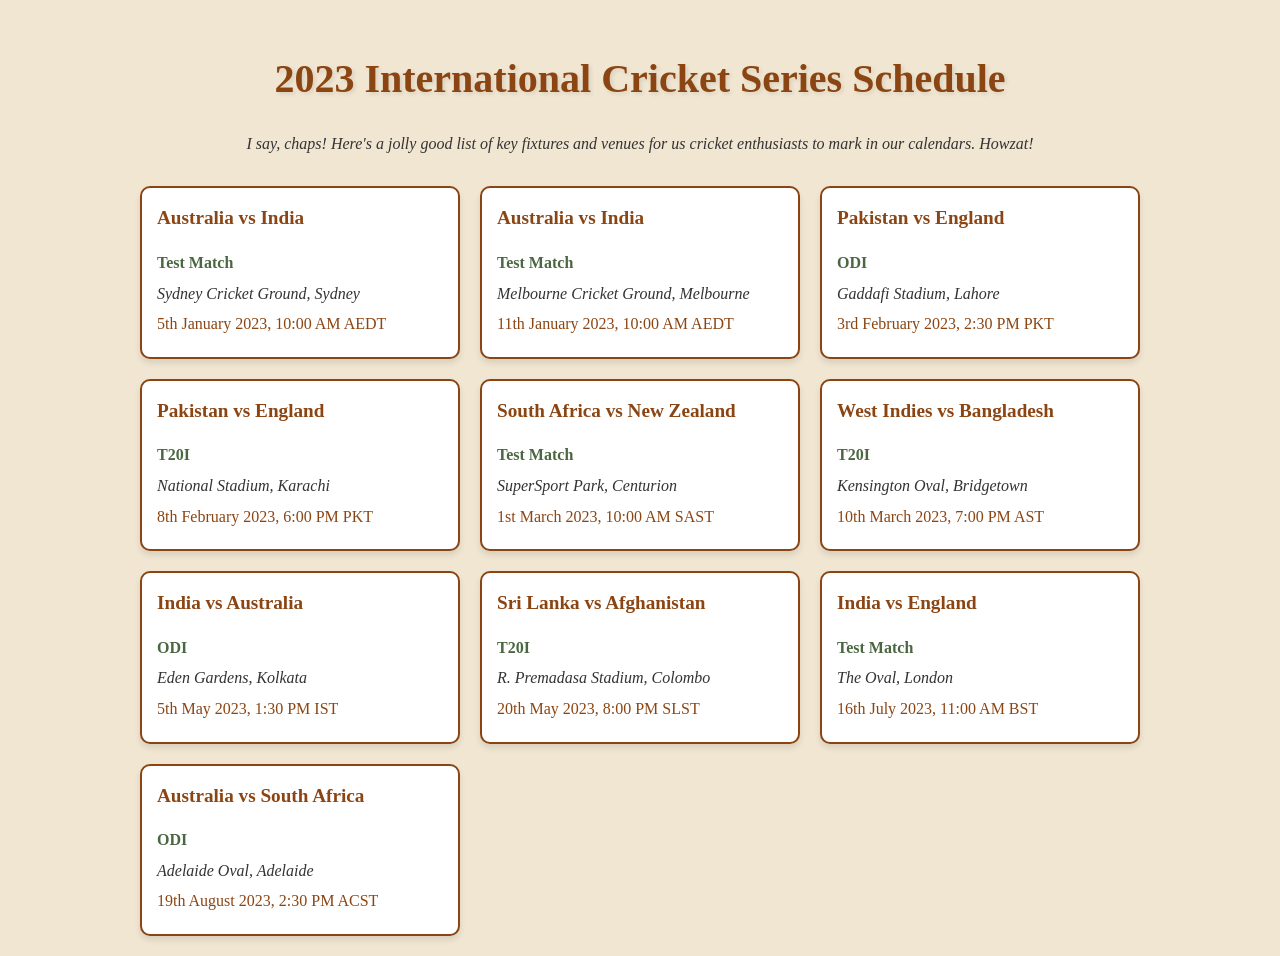What is the first match listed in the schedule? The document presents the match details in the order they appear, with the first being between Australia and India.
Answer: Australia vs India When is the match between Pakistan and England scheduled? The match is listed as taking place on 3rd February 2023.
Answer: 3rd February 2023 What format is the match between West Indies and Bangladesh? The document specifies the match format in each entry, indicating it is a T20I.
Answer: T20I Which venue will host the Test match between India and England? The match location is identified as The Oval, which is mentioned in the venue section of the respective match.
Answer: The Oval How many matches are scheduled for Australia in January 2023? Counting the matches listed for Australia, there are two scheduled in January 2023.
Answer: 2 What time is the Sri Lanka vs Afghanistan T20I match set to start? The time of the match is stated in the time section, specifically at 8:00 PM SLST.
Answer: 8:00 PM SLST What is the last match listed in the schedule? The document concludes with the match information for Australia against South Africa.
Answer: Australia vs South Africa Which country is playing a Test match in London? The match details reveal that India is playing a Test match at The Oval in London.
Answer: India 